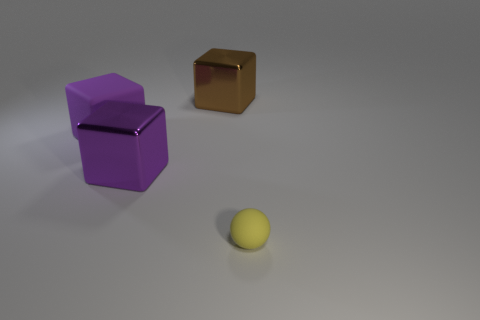There is a big matte object; does it have the same shape as the large metal thing to the left of the large brown metallic object?
Provide a succinct answer. Yes. How many large objects are either red shiny cylinders or purple objects?
Give a very brief answer. 2. Are there any purple matte things of the same size as the brown metallic object?
Provide a succinct answer. Yes. There is a big object in front of the rubber object that is behind the small yellow thing that is right of the big purple metal cube; what is its color?
Give a very brief answer. Purple. Are the tiny yellow object and the large object that is behind the purple rubber block made of the same material?
Your answer should be compact. No. What size is the brown object that is the same shape as the purple rubber thing?
Your response must be concise. Large. Are there the same number of matte blocks behind the large brown metal object and brown metal cubes on the left side of the large purple rubber block?
Your answer should be compact. Yes. What number of other objects are the same material as the large brown cube?
Give a very brief answer. 1. Are there the same number of large purple matte blocks that are to the right of the big purple rubber block and tiny gray rubber balls?
Provide a succinct answer. Yes. Do the purple rubber block and the metal cube that is in front of the large brown thing have the same size?
Ensure brevity in your answer.  Yes. 